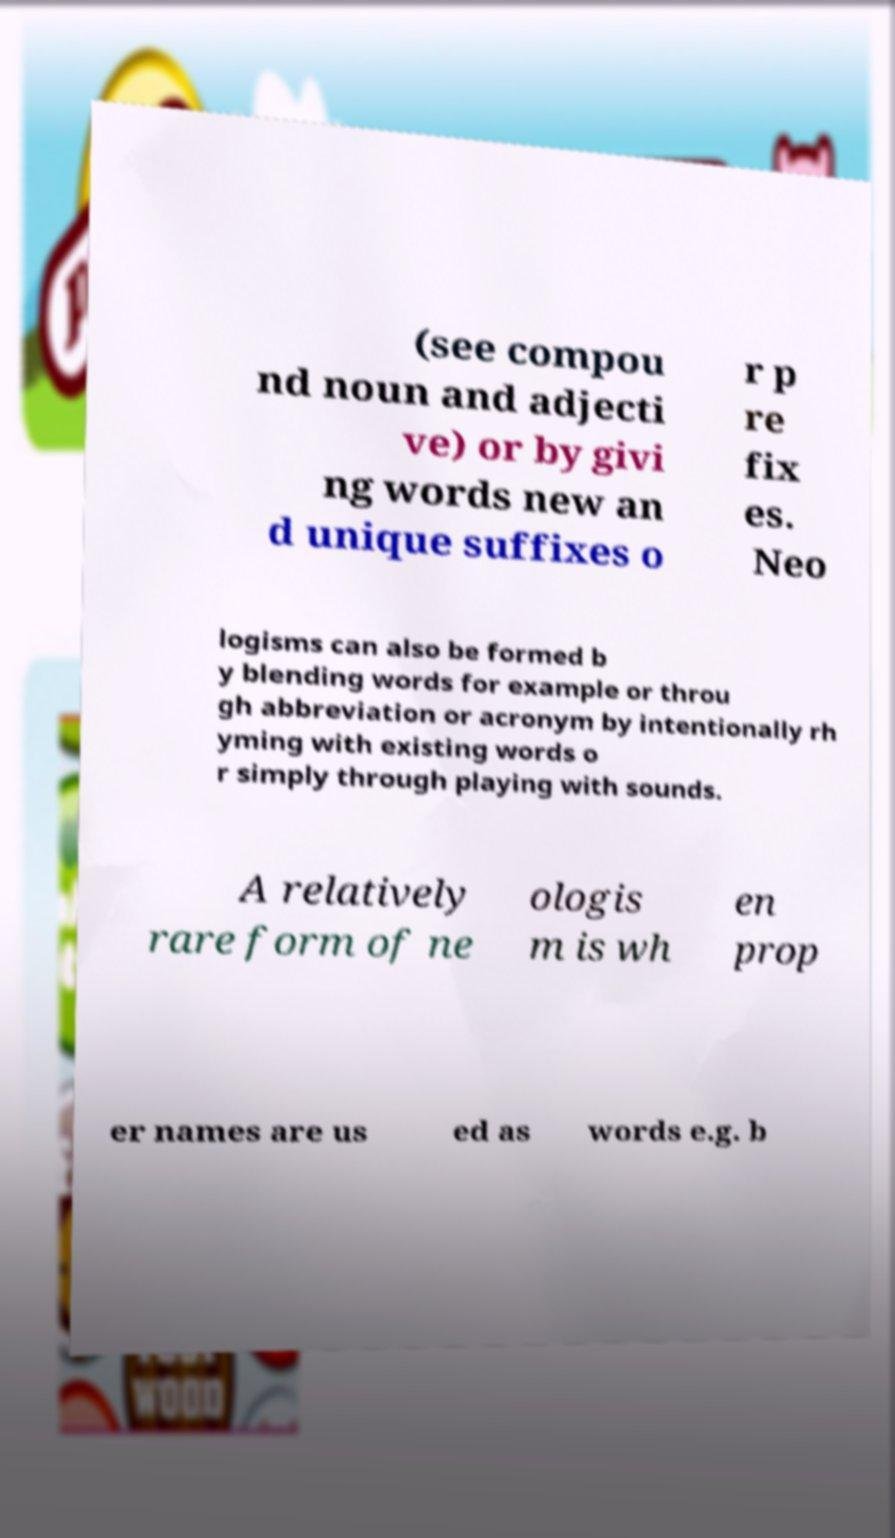Could you assist in decoding the text presented in this image and type it out clearly? (see compou nd noun and adjecti ve) or by givi ng words new an d unique suffixes o r p re fix es. Neo logisms can also be formed b y blending words for example or throu gh abbreviation or acronym by intentionally rh yming with existing words o r simply through playing with sounds. A relatively rare form of ne ologis m is wh en prop er names are us ed as words e.g. b 